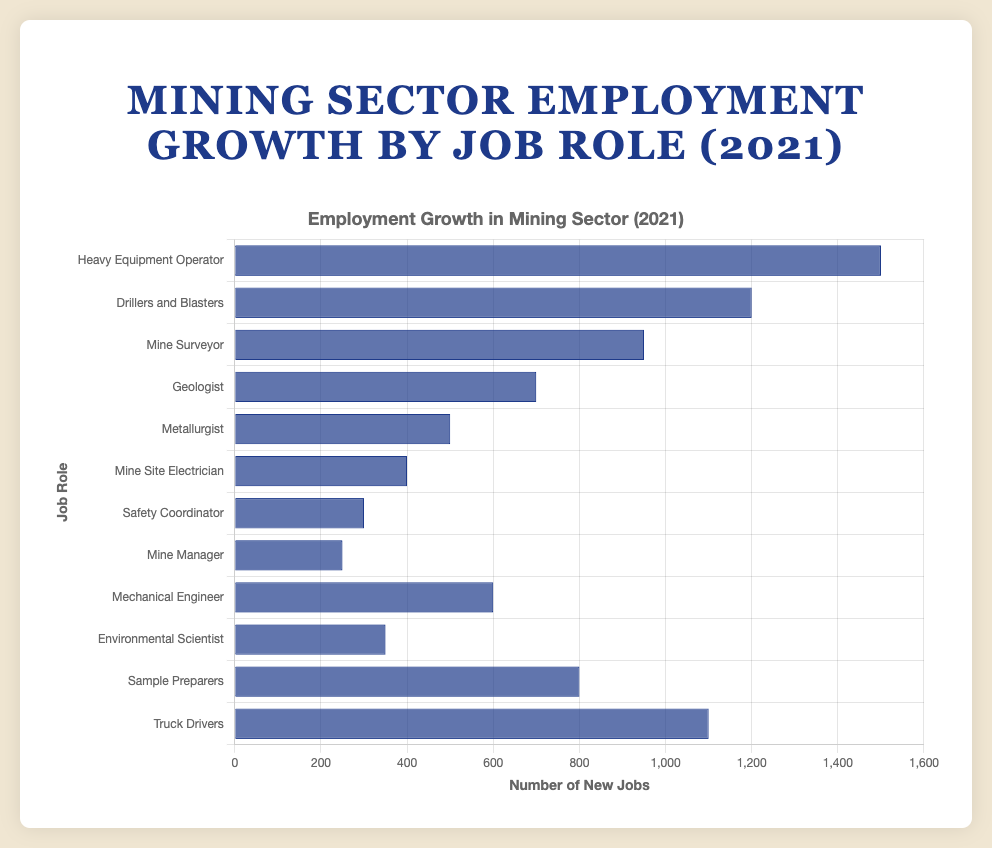Which job role saw the highest employment growth in the mining sector in 2021? The figure shows a bar chart of employment growth by job role. The highest bar represents the job role with the highest employment growth.
Answer: Heavy Equipment Operator Which job role saw the lowest employment growth in the mining sector in 2021? The lowest bar represents the job role with the lowest employment growth.
Answer: Mine Manager How much more did the employment growth of Heavy Equipment Operators exceed the employment growth of Metallurgists? The employment growth for Heavy Equipment Operators is 1500 and for Metallurgists is 500. The difference is 1500 - 500.
Answer: 1000 What is the total employment growth for the roles of Drillers and Blasters, Truck Drivers, and Sample Preparers combined? The employment growth for Drillers and Blasters is 1200, Truck Drivers is 1100, and Sample Preparers is 800. The sum is 1200 + 1100 + 800.
Answer: 3100 Which job role has a higher employment growth: Geologist or Environmental Scientist? The employment growth of Geologists is 700, and for Environmental Scientists is 350. Geologists have a higher employment growth.
Answer: Geologist What is the average employment growth for the job roles Mine Surveyor, Geologist, and Metallurgist? The employment growth for Mine Surveyor is 950, Geologist is 700, and Metallurgist is 500. The total is 950 + 700 + 500 = 2150. The average is 2150 / 3.
Answer: 717 How does the employment growth of Mine Site Electricians compare to that of Mechanical Engineers? The employment growth for Mine Site Electricians is 400, and for Mechanical Engineers is 600. Mechanical Engineers have a higher employment growth.
Answer: Mechanical Engineers By how much does the employment growth of the highest role exceed the employment growth of the lowest role? The highest employment growth is 1500 (Heavy Equipment Operator), and the lowest is 250 (Mine Manager). The difference is 1500 - 250.
Answer: 1250 What is the employment growth range for all the job roles listed? The highest employment growth is 1500 (Heavy Equipment Operator) and the lowest is 250 (Mine Manager). The range is 1500 - 250.
Answer: 1250 